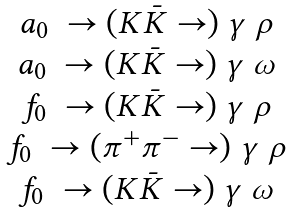Convert formula to latex. <formula><loc_0><loc_0><loc_500><loc_500>\begin{matrix} a _ { 0 } \ \to ( K \bar { K } \to ) \ \gamma \ \rho \\ a _ { 0 } \ \to ( K \bar { K } \to ) \ \gamma \ \omega \\ f _ { 0 } \ \to ( K \bar { K } \to ) \ \gamma \ \rho \\ f _ { 0 } \ \to ( \pi ^ { + } \pi ^ { - } \to ) \ \gamma \ \rho \\ f _ { 0 } \ \to ( K \bar { K } \to ) \ \gamma \ \omega \end{matrix}</formula> 